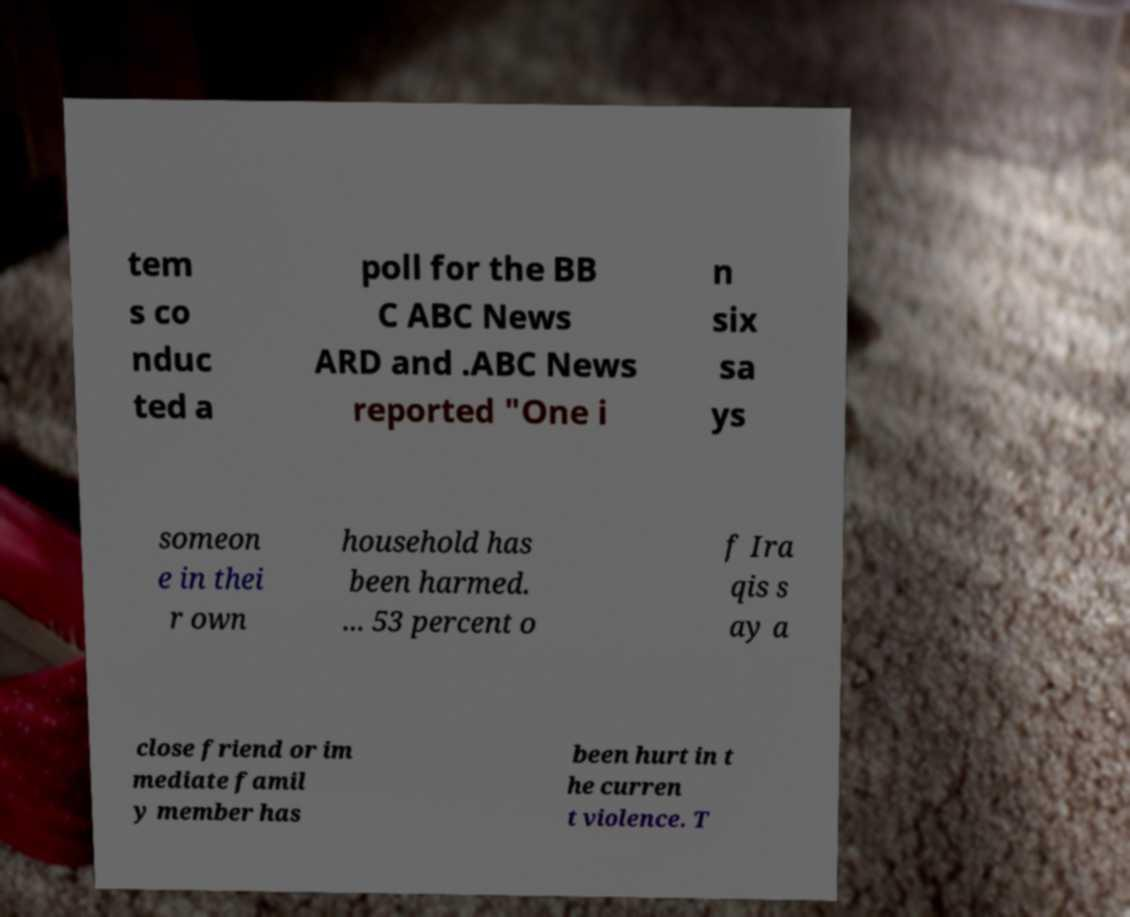What messages or text are displayed in this image? I need them in a readable, typed format. tem s co nduc ted a poll for the BB C ABC News ARD and .ABC News reported "One i n six sa ys someon e in thei r own household has been harmed. ... 53 percent o f Ira qis s ay a close friend or im mediate famil y member has been hurt in t he curren t violence. T 